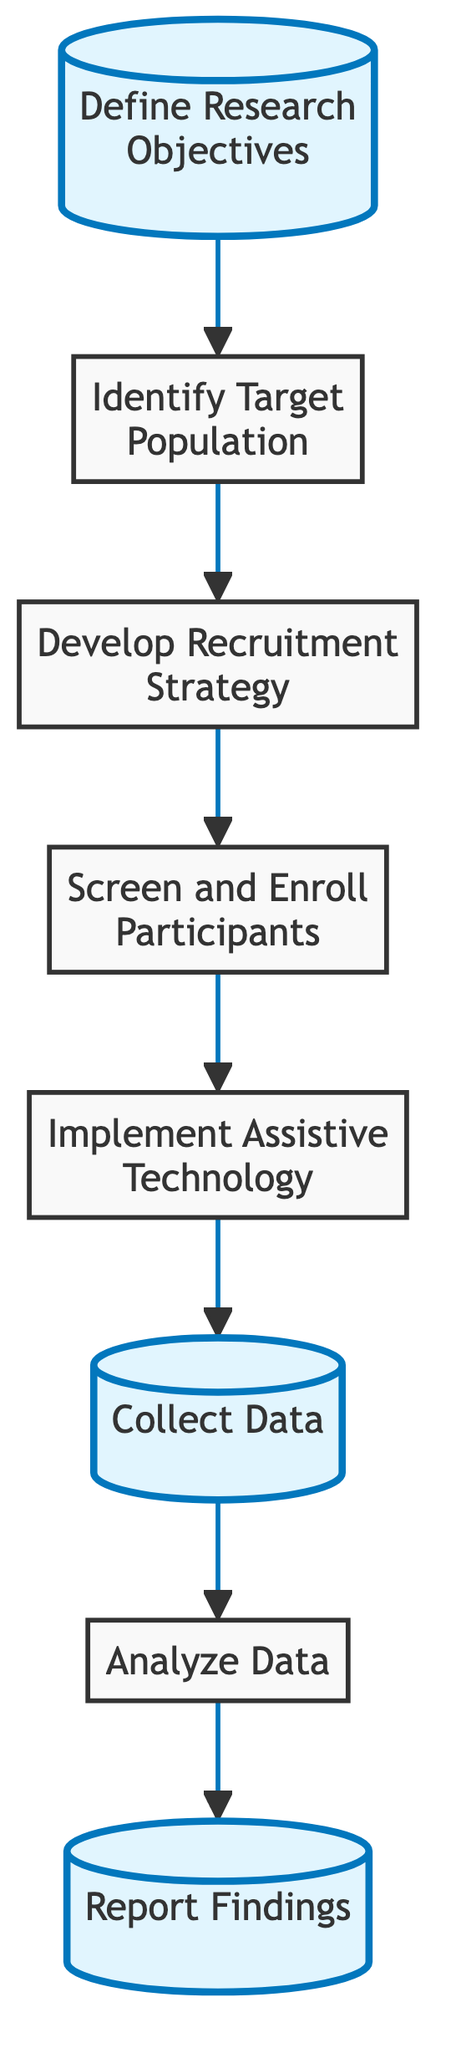What is the first step in the workflow? The first step in the workflow is represented by node 1, which states "Define Research Objectives." This is the starting point in the flowchart that outlines the research process.
Answer: Define Research Objectives How many nodes are there in the diagram? The diagram contains a total of 8 nodes. This includes all the steps from defining research objectives to reporting findings.
Answer: 8 What is the last step in the research workflow? The last step in the workflow is represented by node 8, which states "Report Findings." This concludes the research process.
Answer: Report Findings Which phase involves participant recruitment? The participant recruitment phase is depicted from nodes 2 to 4, which includes identifying the target population, developing a recruitment strategy, and screening and enrolling participants.
Answer: 2 to 4 What comes directly after data collection? After the data collection phase, which is node 6, the next step is data analysis, represented by node 7. This indicates the progression from gathering data to analyzing it.
Answer: Analyze Data What is the relationship between "Implement Assistive Technology" and "Collect Data"? "Implement Assistive Technology" is node 5 and directly leads to "Collect Data," which is node 6, indicating that once the technology is implemented, data collection can begin.
Answer: Directly leads to Which step highlights the data collection process? The step that highlights the data collection process is node 6, which explicitly states "Collect Data." This indicates its importance in the workflow, set apart by the use of highlighting in the diagram.
Answer: Collect Data What is the purpose of screening and enrolling participants? The purpose of screening and enrolling participants, as shown in node 4, is to assess eligibility and obtain informed consent from participants for the study.
Answer: Assess eligibility and obtain informed consent Which nodes are highlighted in the diagram? The highlighted nodes in the diagram are nodes 1, 6, and 8, which respectively represent "Define Research Objectives," "Collect Data," and "Report Findings." These highlights indicate key phases in the research workflow.
Answer: 1, 6, and 8 